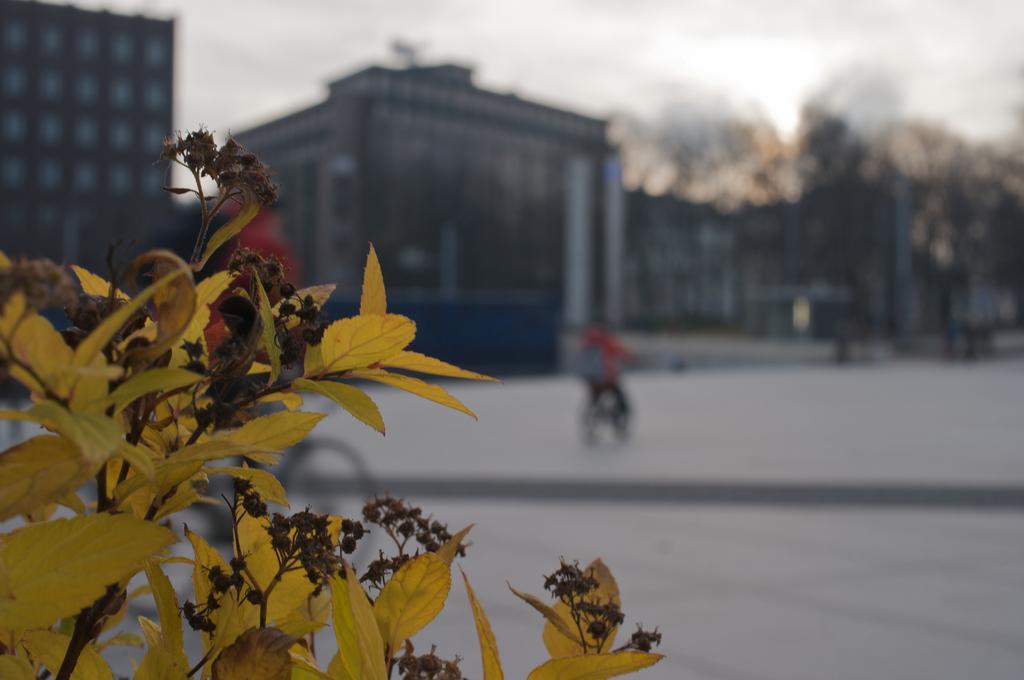In one or two sentences, can you explain what this image depicts? In this picture we can see a plant, in the background we can find few buildings, trees and a person is riding bicycle. 